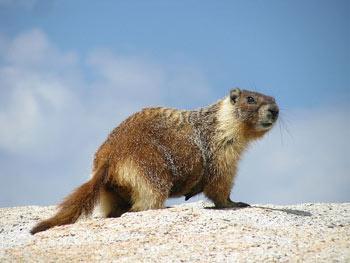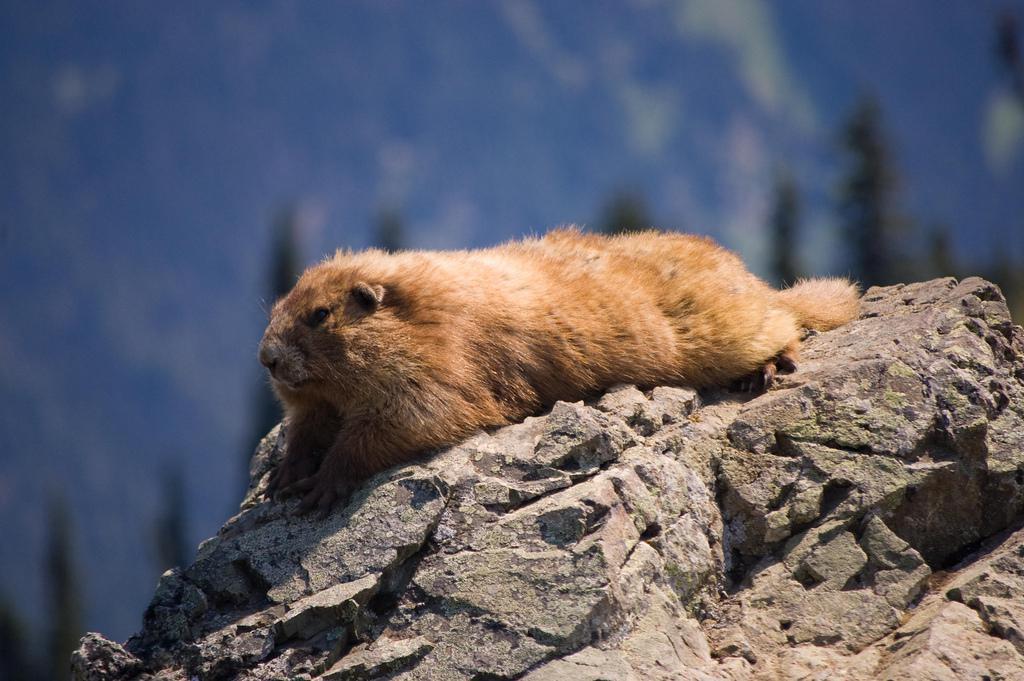The first image is the image on the left, the second image is the image on the right. Examine the images to the left and right. Is the description "In one of the images, there is a marmot standing up on its hind legs" accurate? Answer yes or no. No. 